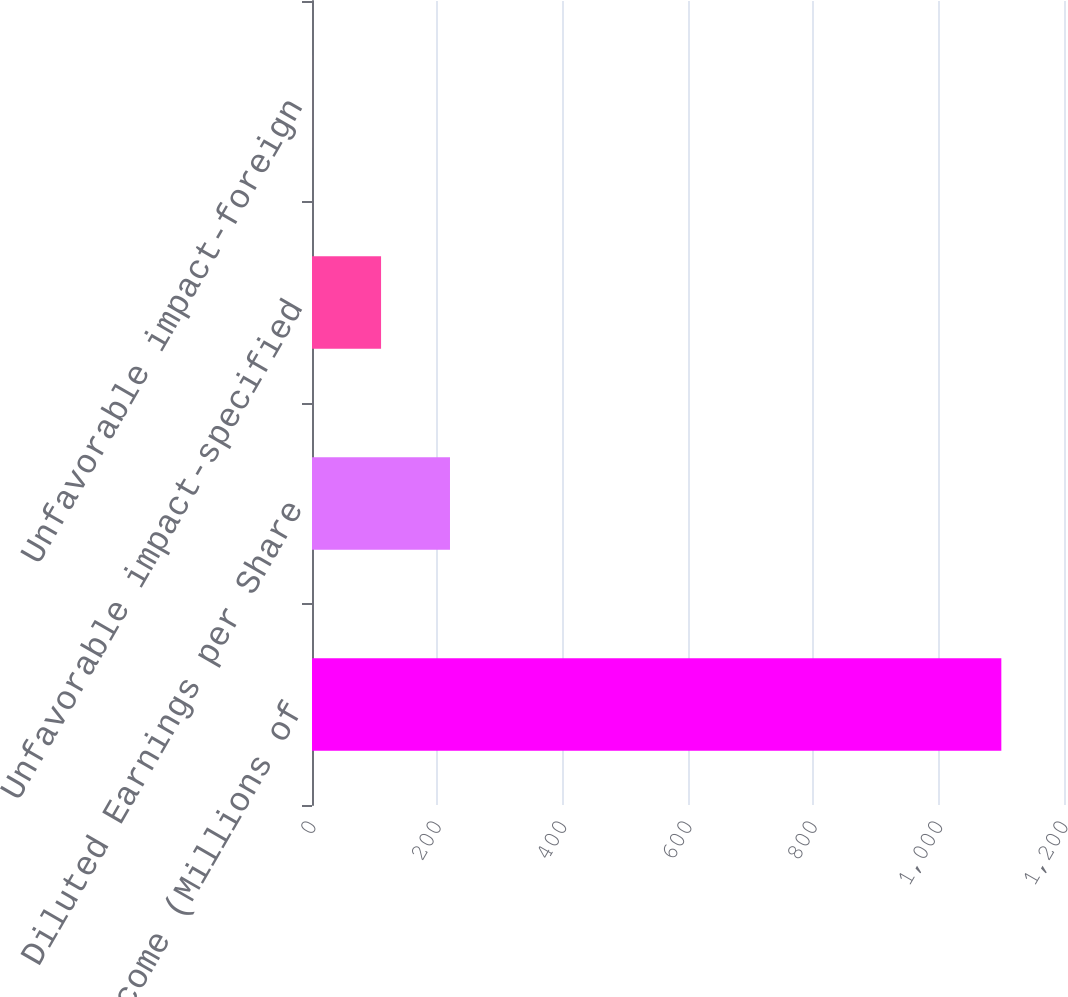Convert chart to OTSL. <chart><loc_0><loc_0><loc_500><loc_500><bar_chart><fcel>Net income (Millions of<fcel>Diluted Earnings per Share<fcel>Unfavorable impact-specified<fcel>Unfavorable impact-foreign<nl><fcel>1100<fcel>220.19<fcel>110.21<fcel>0.23<nl></chart> 